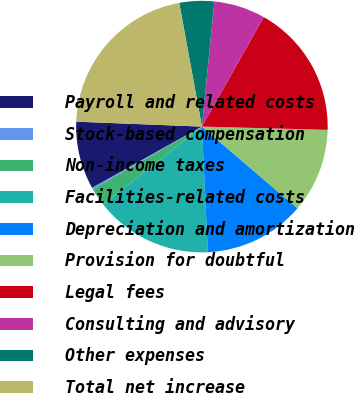Convert chart. <chart><loc_0><loc_0><loc_500><loc_500><pie_chart><fcel>Payroll and related costs<fcel>Stock-based compensation<fcel>Non-income taxes<fcel>Facilities-related costs<fcel>Depreciation and amortization<fcel>Provision for doubtful<fcel>Legal fees<fcel>Consulting and advisory<fcel>Other expenses<fcel>Total net increase<nl><fcel>8.72%<fcel>0.21%<fcel>2.34%<fcel>15.11%<fcel>12.98%<fcel>10.85%<fcel>17.23%<fcel>6.6%<fcel>4.47%<fcel>21.49%<nl></chart> 